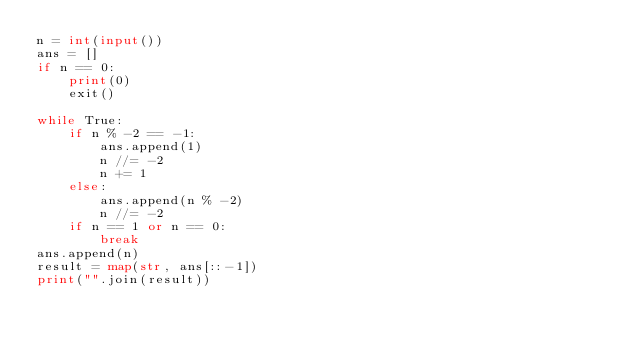<code> <loc_0><loc_0><loc_500><loc_500><_Python_>n = int(input())
ans = []
if n == 0:
    print(0)
    exit()

while True:
    if n % -2 == -1:
        ans.append(1)
        n //= -2
        n += 1
    else:
        ans.append(n % -2)
        n //= -2
    if n == 1 or n == 0:
        break
ans.append(n)
result = map(str, ans[::-1])
print("".join(result))</code> 